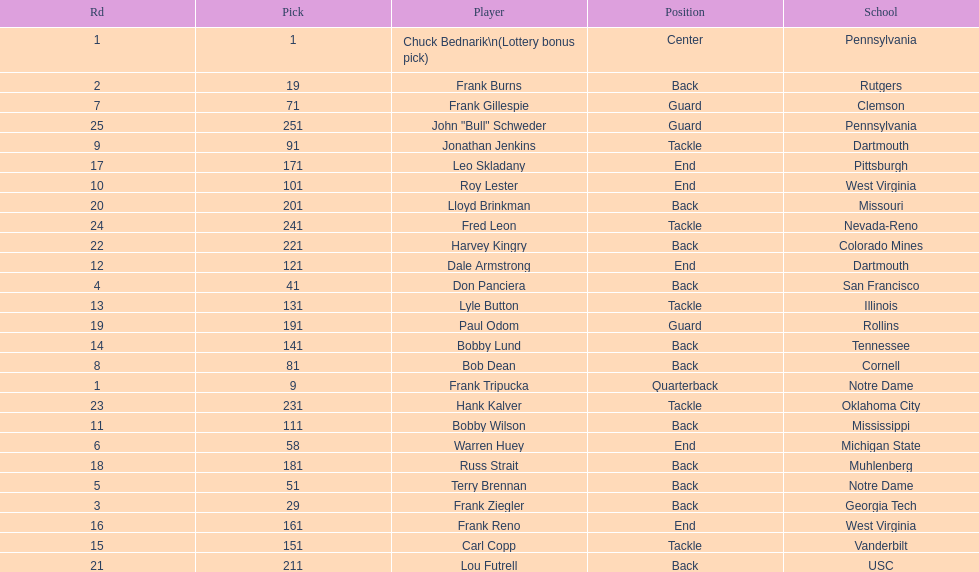How many players were from notre dame? 2. 